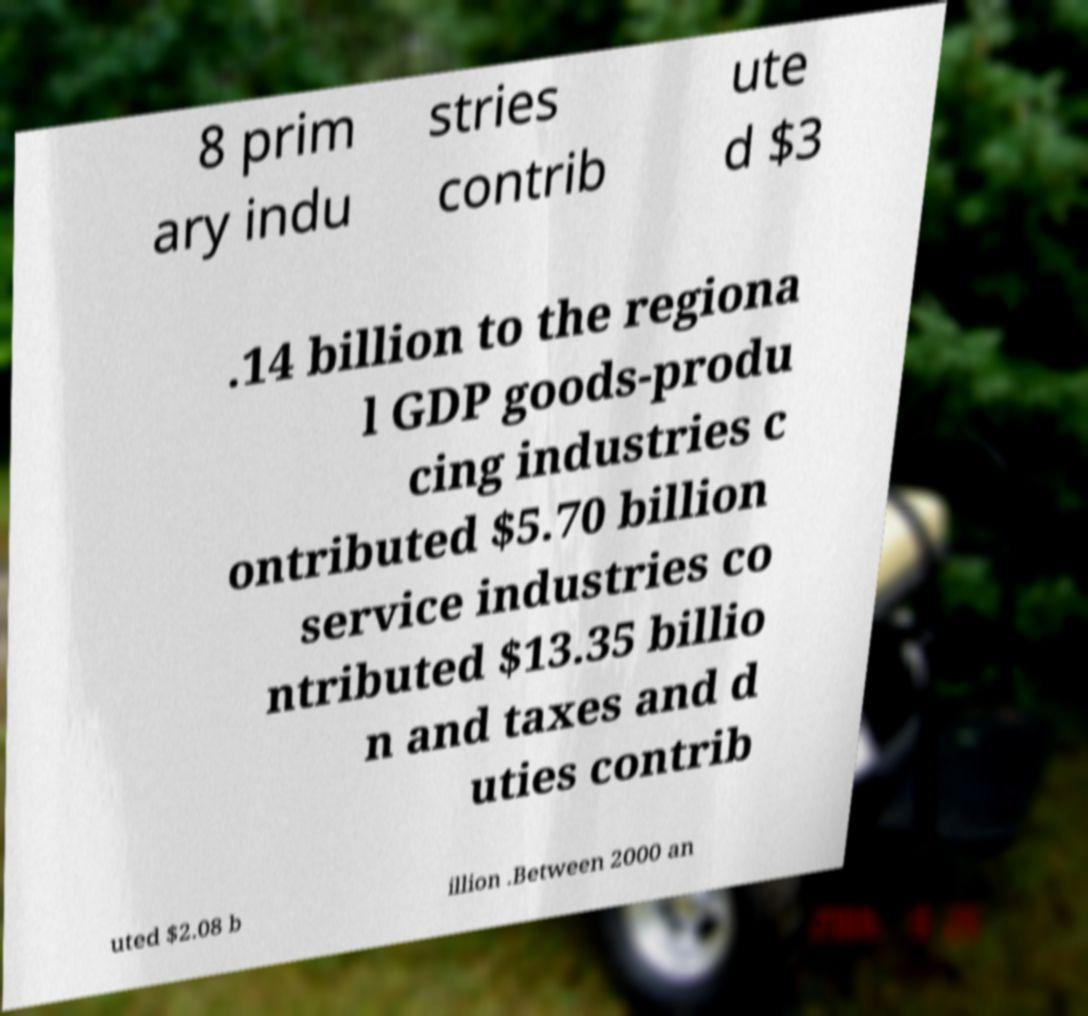Please read and relay the text visible in this image. What does it say? 8 prim ary indu stries contrib ute d $3 .14 billion to the regiona l GDP goods-produ cing industries c ontributed $5.70 billion service industries co ntributed $13.35 billio n and taxes and d uties contrib uted $2.08 b illion .Between 2000 an 